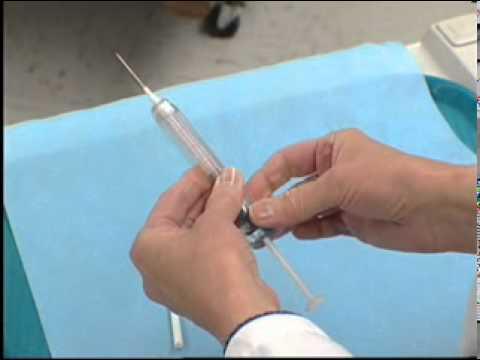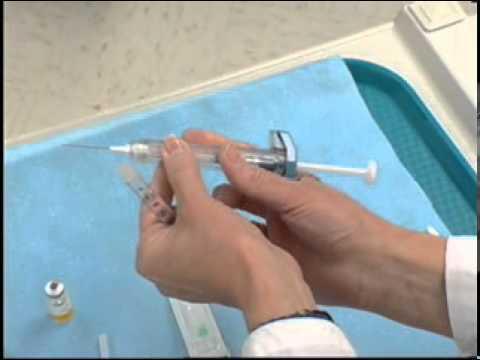The first image is the image on the left, the second image is the image on the right. Given the left and right images, does the statement "There are four bare hands working with needles." hold true? Answer yes or no. Yes. The first image is the image on the left, the second image is the image on the right. For the images shown, is this caption "At least one needle attached to a syringe is visible." true? Answer yes or no. Yes. 